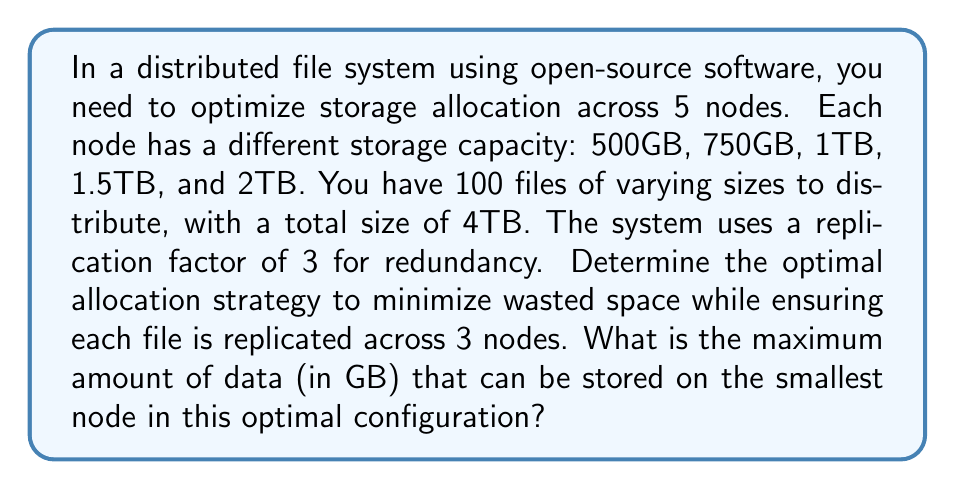What is the answer to this math problem? To solve this optimization problem, we need to follow these steps:

1. Calculate the total available storage:
   $$ 500 + 750 + 1000 + 1500 + 2000 = 5750 \text{ GB} $$

2. Calculate the total required storage with replication:
   $$ 4000 \text{ GB} \times 3 = 12000 \text{ GB} $$

3. Since the required storage (12000 GB) is greater than the available storage (5750 GB), we need to utilize all available space efficiently.

4. To minimize wasted space, we should try to distribute the data as evenly as possible across all nodes, considering their capacities.

5. Calculate the proportion of each node's capacity to the total capacity:
   $$ \begin{align}
   500 / 5750 &\approx 0.087 \\
   750 / 5750 &\approx 0.130 \\
   1000 / 5750 &\approx 0.174 \\
   1500 / 5750 &\approx 0.261 \\
   2000 / 5750 &\approx 0.348
   \end{align} $$

6. Multiply these proportions by the total data size (4000 GB) to get the optimal allocation for each node:
   $$ \begin{align}
   500 \text{ GB node}: 4000 \times 0.087 &\approx 348 \text{ GB} \\
   750 \text{ GB node}: 4000 \times 0.130 &\approx 520 \text{ GB} \\
   1000 \text{ GB node}: 4000 \times 0.174 &\approx 696 \text{ GB} \\
   1500 \text{ GB node}: 4000 \times 0.261 &\approx 1044 \text{ GB} \\
   2000 \text{ GB node}: 4000 \times 0.348 &\approx 1392 \text{ GB}
   \end{align} $$

7. The smallest node (500 GB) can optimally store 348 GB of data in this configuration.

This allocation strategy ensures that each node stores an amount of data proportional to its capacity, minimizing wasted space while maintaining the replication factor of 3 across the system.
Answer: 348 GB 